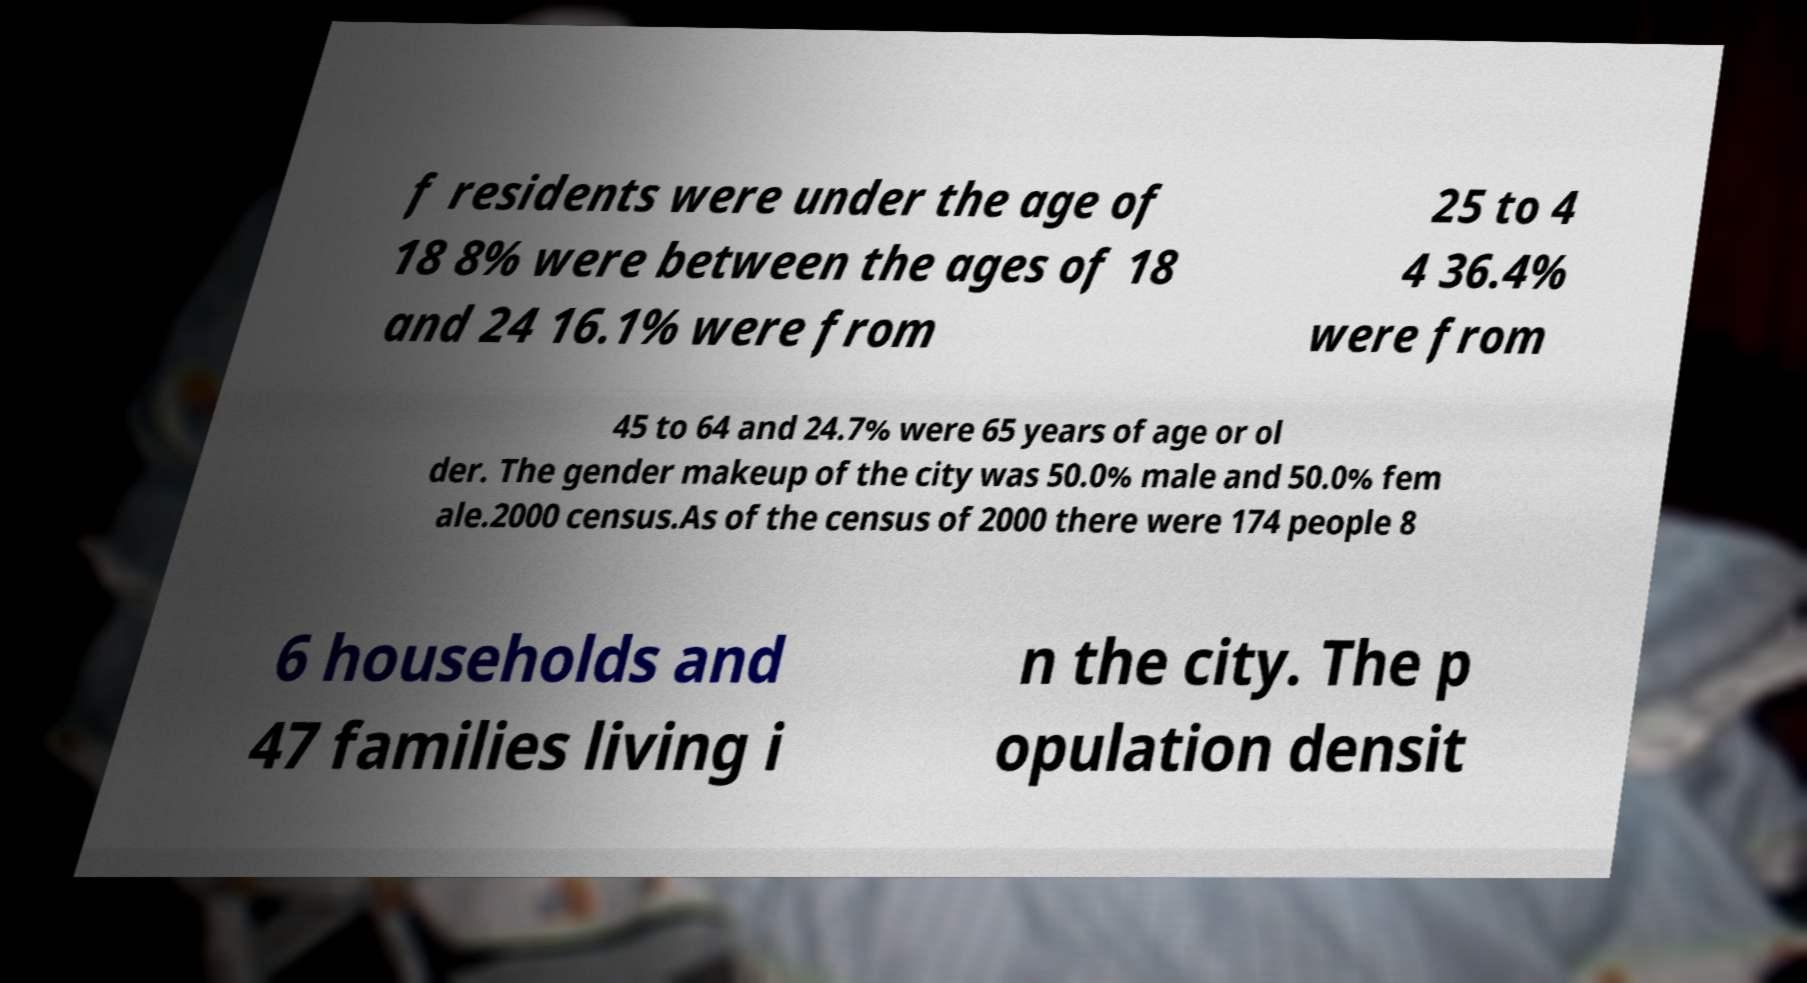For documentation purposes, I need the text within this image transcribed. Could you provide that? f residents were under the age of 18 8% were between the ages of 18 and 24 16.1% were from 25 to 4 4 36.4% were from 45 to 64 and 24.7% were 65 years of age or ol der. The gender makeup of the city was 50.0% male and 50.0% fem ale.2000 census.As of the census of 2000 there were 174 people 8 6 households and 47 families living i n the city. The p opulation densit 